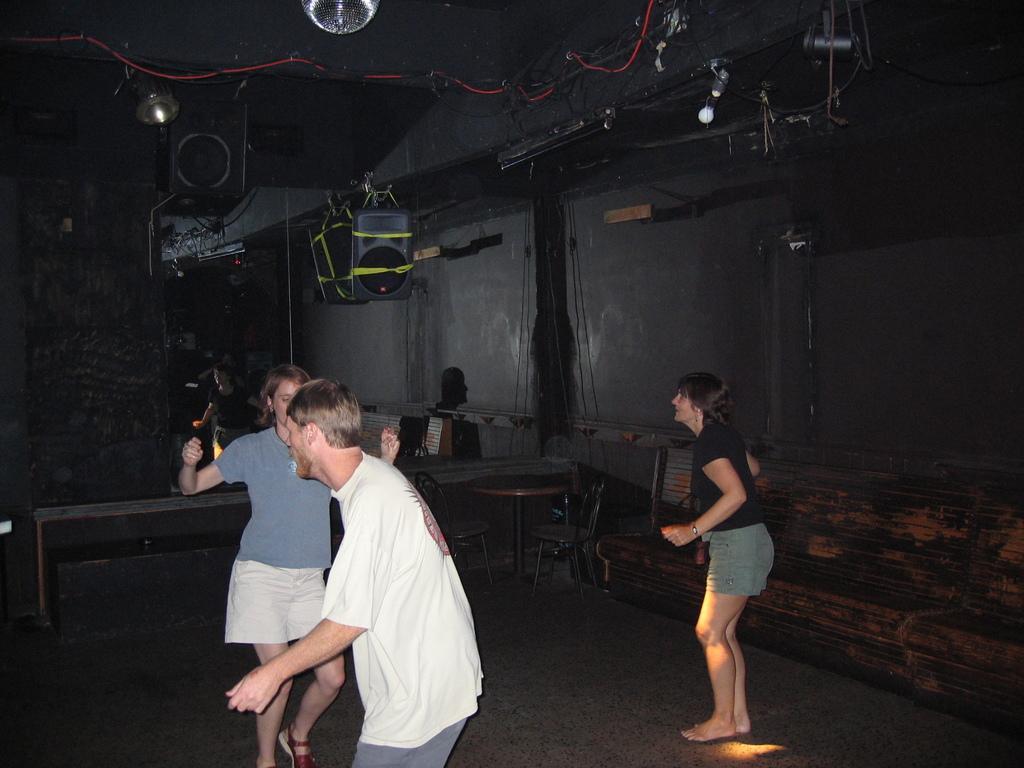Can you describe this image briefly? In this image we can see few people. In the back there is a table. Also there are chairs. On the ceiling we can see bulbs and wires. Also there is a wall and some other objects. 